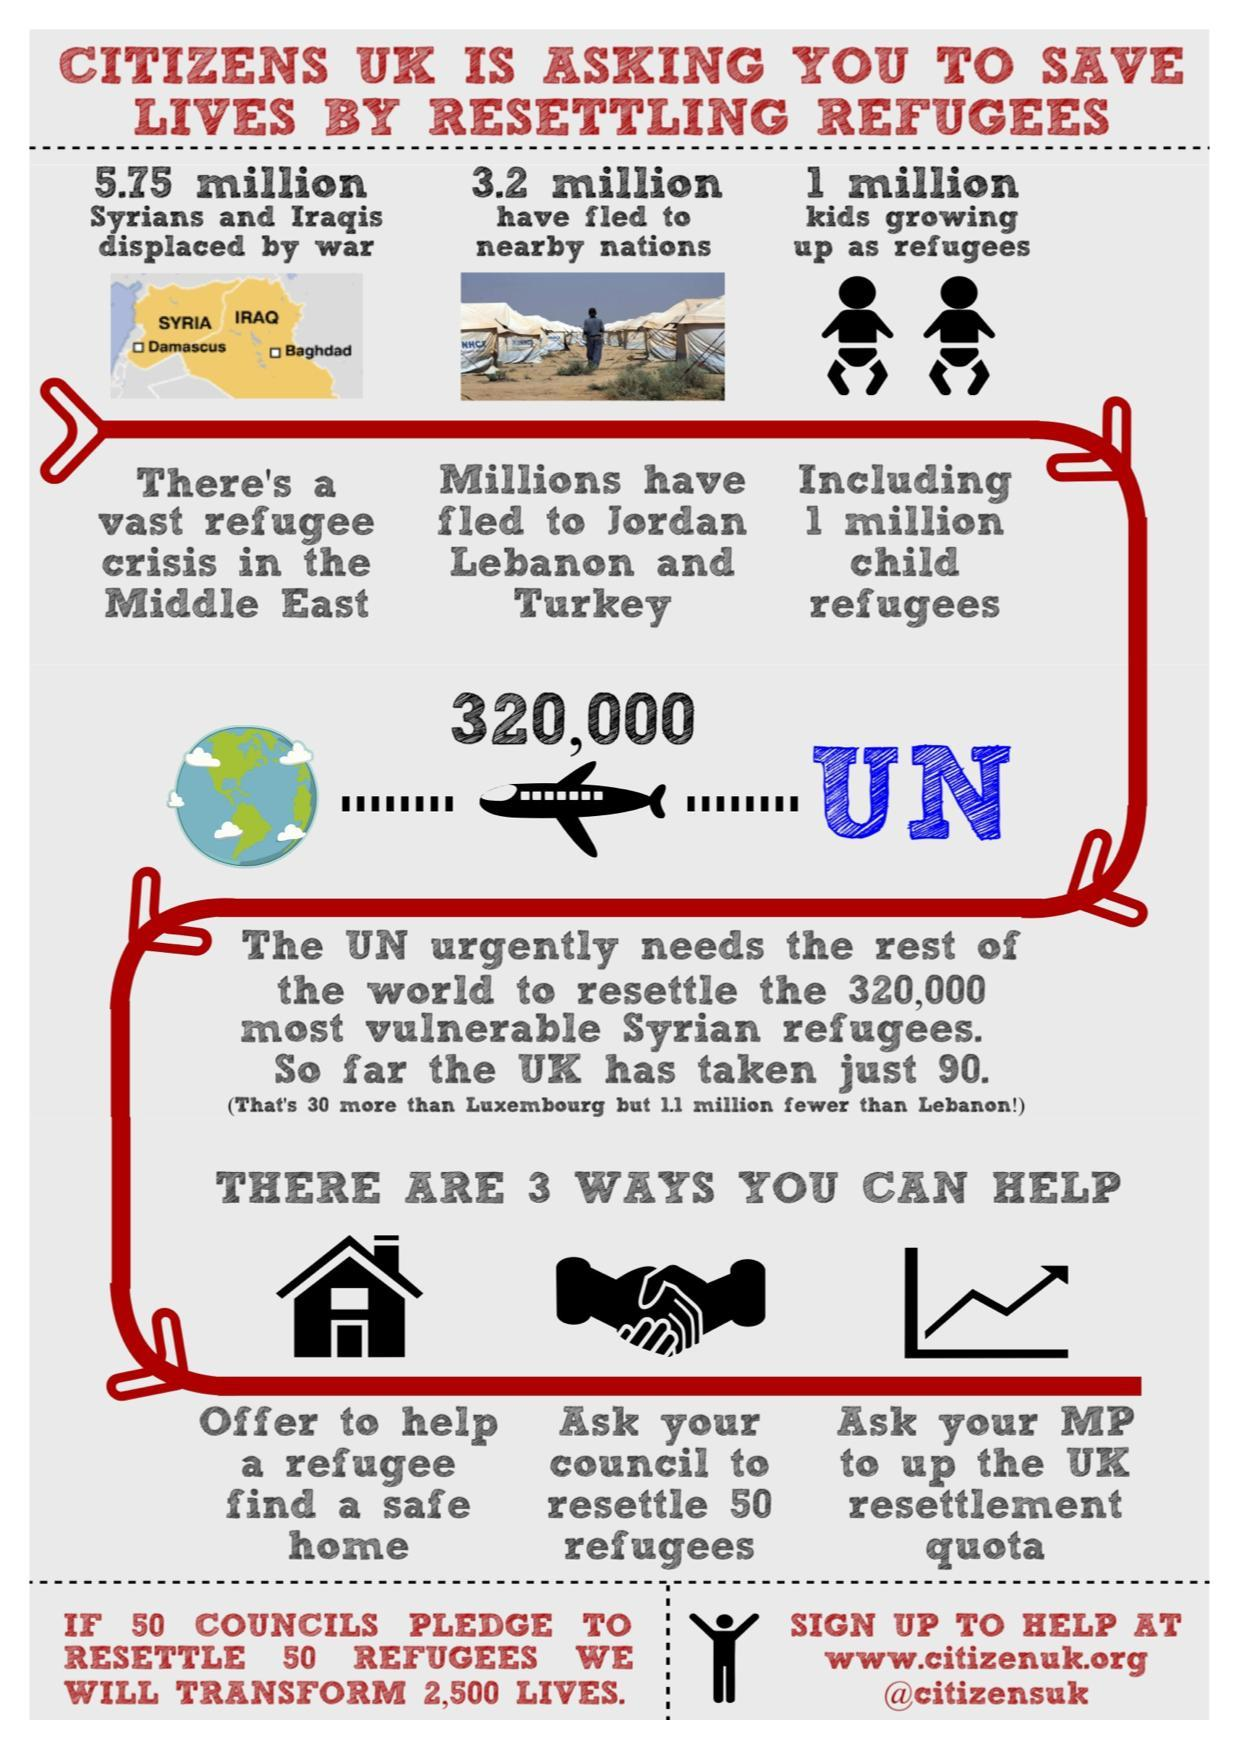How many vulnerable Syrian refugees were taken by the UK council?
Answer the question with a short phrase. just 90. How many refugees are there in the Middle East? 5.75 million What is the child refugees population? 1 million What is the refugee population who have fled to Jordan, Lebanon & Turkey? 3.2 million 